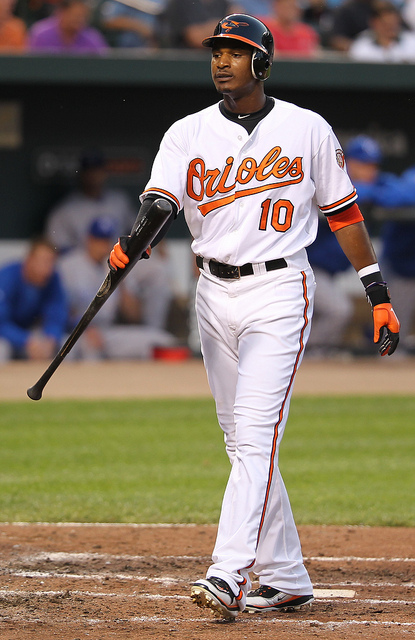Identify the text contained in this image. Orioles 10 